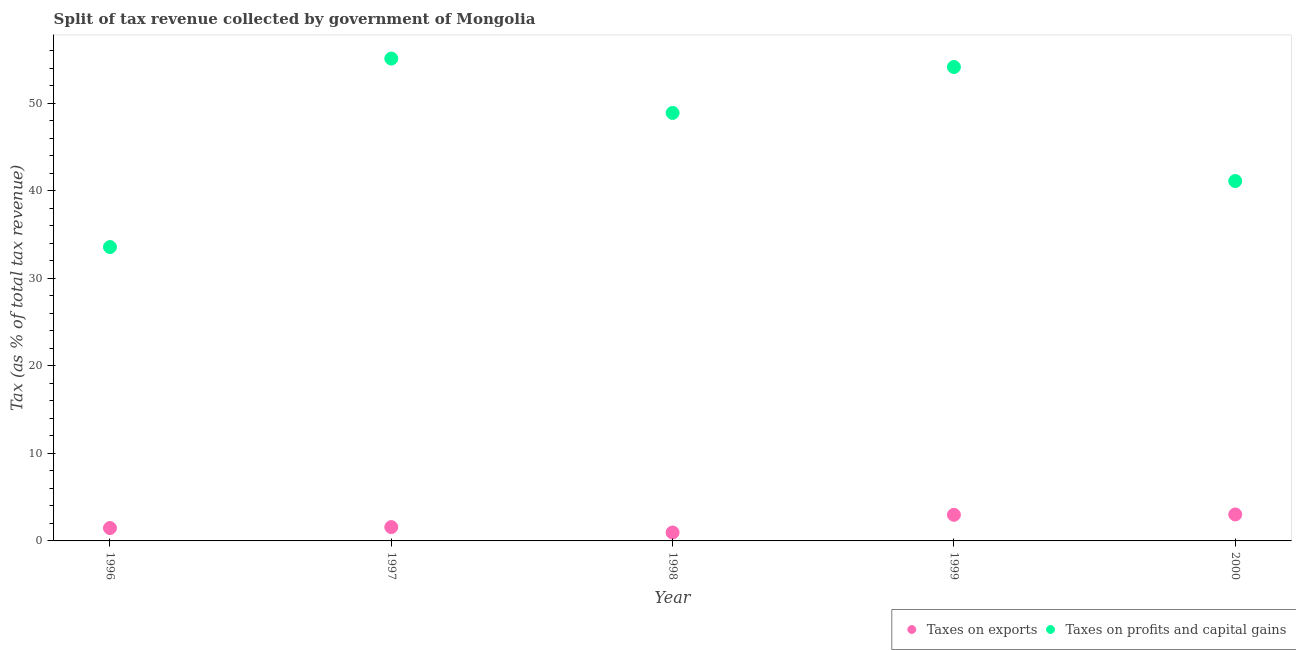How many different coloured dotlines are there?
Your answer should be very brief. 2. What is the percentage of revenue obtained from taxes on exports in 1999?
Offer a very short reply. 2.98. Across all years, what is the maximum percentage of revenue obtained from taxes on exports?
Make the answer very short. 3.03. Across all years, what is the minimum percentage of revenue obtained from taxes on profits and capital gains?
Keep it short and to the point. 33.59. In which year was the percentage of revenue obtained from taxes on profits and capital gains maximum?
Give a very brief answer. 1997. In which year was the percentage of revenue obtained from taxes on exports minimum?
Ensure brevity in your answer.  1998. What is the total percentage of revenue obtained from taxes on exports in the graph?
Provide a succinct answer. 10.02. What is the difference between the percentage of revenue obtained from taxes on profits and capital gains in 1996 and that in 1999?
Your answer should be compact. -20.57. What is the difference between the percentage of revenue obtained from taxes on profits and capital gains in 1996 and the percentage of revenue obtained from taxes on exports in 2000?
Your response must be concise. 30.56. What is the average percentage of revenue obtained from taxes on profits and capital gains per year?
Give a very brief answer. 46.58. In the year 1998, what is the difference between the percentage of revenue obtained from taxes on exports and percentage of revenue obtained from taxes on profits and capital gains?
Offer a very short reply. -47.95. What is the ratio of the percentage of revenue obtained from taxes on profits and capital gains in 1999 to that in 2000?
Keep it short and to the point. 1.32. What is the difference between the highest and the second highest percentage of revenue obtained from taxes on profits and capital gains?
Your answer should be very brief. 0.97. What is the difference between the highest and the lowest percentage of revenue obtained from taxes on exports?
Provide a succinct answer. 2.06. In how many years, is the percentage of revenue obtained from taxes on exports greater than the average percentage of revenue obtained from taxes on exports taken over all years?
Your response must be concise. 2. Is the sum of the percentage of revenue obtained from taxes on profits and capital gains in 1998 and 1999 greater than the maximum percentage of revenue obtained from taxes on exports across all years?
Give a very brief answer. Yes. Does the percentage of revenue obtained from taxes on exports monotonically increase over the years?
Your response must be concise. No. Is the percentage of revenue obtained from taxes on exports strictly less than the percentage of revenue obtained from taxes on profits and capital gains over the years?
Offer a very short reply. Yes. Does the graph contain any zero values?
Ensure brevity in your answer.  No. Does the graph contain grids?
Give a very brief answer. No. Where does the legend appear in the graph?
Offer a very short reply. Bottom right. How are the legend labels stacked?
Your response must be concise. Horizontal. What is the title of the graph?
Provide a short and direct response. Split of tax revenue collected by government of Mongolia. Does "Start a business" appear as one of the legend labels in the graph?
Offer a terse response. No. What is the label or title of the Y-axis?
Make the answer very short. Tax (as % of total tax revenue). What is the Tax (as % of total tax revenue) of Taxes on exports in 1996?
Keep it short and to the point. 1.47. What is the Tax (as % of total tax revenue) of Taxes on profits and capital gains in 1996?
Provide a short and direct response. 33.59. What is the Tax (as % of total tax revenue) in Taxes on exports in 1997?
Your answer should be very brief. 1.58. What is the Tax (as % of total tax revenue) of Taxes on profits and capital gains in 1997?
Your response must be concise. 55.12. What is the Tax (as % of total tax revenue) in Taxes on exports in 1998?
Offer a terse response. 0.96. What is the Tax (as % of total tax revenue) of Taxes on profits and capital gains in 1998?
Keep it short and to the point. 48.91. What is the Tax (as % of total tax revenue) of Taxes on exports in 1999?
Make the answer very short. 2.98. What is the Tax (as % of total tax revenue) of Taxes on profits and capital gains in 1999?
Make the answer very short. 54.16. What is the Tax (as % of total tax revenue) of Taxes on exports in 2000?
Make the answer very short. 3.03. What is the Tax (as % of total tax revenue) in Taxes on profits and capital gains in 2000?
Provide a short and direct response. 41.13. Across all years, what is the maximum Tax (as % of total tax revenue) of Taxes on exports?
Offer a terse response. 3.03. Across all years, what is the maximum Tax (as % of total tax revenue) of Taxes on profits and capital gains?
Your answer should be very brief. 55.12. Across all years, what is the minimum Tax (as % of total tax revenue) in Taxes on exports?
Your answer should be compact. 0.96. Across all years, what is the minimum Tax (as % of total tax revenue) of Taxes on profits and capital gains?
Provide a short and direct response. 33.59. What is the total Tax (as % of total tax revenue) of Taxes on exports in the graph?
Keep it short and to the point. 10.02. What is the total Tax (as % of total tax revenue) in Taxes on profits and capital gains in the graph?
Give a very brief answer. 232.91. What is the difference between the Tax (as % of total tax revenue) of Taxes on exports in 1996 and that in 1997?
Offer a very short reply. -0.11. What is the difference between the Tax (as % of total tax revenue) of Taxes on profits and capital gains in 1996 and that in 1997?
Offer a very short reply. -21.54. What is the difference between the Tax (as % of total tax revenue) of Taxes on exports in 1996 and that in 1998?
Make the answer very short. 0.51. What is the difference between the Tax (as % of total tax revenue) in Taxes on profits and capital gains in 1996 and that in 1998?
Your response must be concise. -15.33. What is the difference between the Tax (as % of total tax revenue) in Taxes on exports in 1996 and that in 1999?
Provide a short and direct response. -1.51. What is the difference between the Tax (as % of total tax revenue) in Taxes on profits and capital gains in 1996 and that in 1999?
Make the answer very short. -20.57. What is the difference between the Tax (as % of total tax revenue) in Taxes on exports in 1996 and that in 2000?
Provide a succinct answer. -1.55. What is the difference between the Tax (as % of total tax revenue) of Taxes on profits and capital gains in 1996 and that in 2000?
Offer a terse response. -7.55. What is the difference between the Tax (as % of total tax revenue) of Taxes on exports in 1997 and that in 1998?
Your answer should be very brief. 0.62. What is the difference between the Tax (as % of total tax revenue) in Taxes on profits and capital gains in 1997 and that in 1998?
Your answer should be compact. 6.21. What is the difference between the Tax (as % of total tax revenue) in Taxes on exports in 1997 and that in 1999?
Provide a succinct answer. -1.4. What is the difference between the Tax (as % of total tax revenue) of Taxes on profits and capital gains in 1997 and that in 1999?
Your answer should be compact. 0.97. What is the difference between the Tax (as % of total tax revenue) in Taxes on exports in 1997 and that in 2000?
Provide a short and direct response. -1.45. What is the difference between the Tax (as % of total tax revenue) in Taxes on profits and capital gains in 1997 and that in 2000?
Your response must be concise. 13.99. What is the difference between the Tax (as % of total tax revenue) in Taxes on exports in 1998 and that in 1999?
Make the answer very short. -2.02. What is the difference between the Tax (as % of total tax revenue) of Taxes on profits and capital gains in 1998 and that in 1999?
Your answer should be very brief. -5.25. What is the difference between the Tax (as % of total tax revenue) of Taxes on exports in 1998 and that in 2000?
Offer a very short reply. -2.06. What is the difference between the Tax (as % of total tax revenue) of Taxes on profits and capital gains in 1998 and that in 2000?
Provide a succinct answer. 7.78. What is the difference between the Tax (as % of total tax revenue) in Taxes on exports in 1999 and that in 2000?
Ensure brevity in your answer.  -0.04. What is the difference between the Tax (as % of total tax revenue) of Taxes on profits and capital gains in 1999 and that in 2000?
Offer a terse response. 13.03. What is the difference between the Tax (as % of total tax revenue) of Taxes on exports in 1996 and the Tax (as % of total tax revenue) of Taxes on profits and capital gains in 1997?
Your answer should be very brief. -53.65. What is the difference between the Tax (as % of total tax revenue) of Taxes on exports in 1996 and the Tax (as % of total tax revenue) of Taxes on profits and capital gains in 1998?
Your answer should be compact. -47.44. What is the difference between the Tax (as % of total tax revenue) in Taxes on exports in 1996 and the Tax (as % of total tax revenue) in Taxes on profits and capital gains in 1999?
Give a very brief answer. -52.69. What is the difference between the Tax (as % of total tax revenue) of Taxes on exports in 1996 and the Tax (as % of total tax revenue) of Taxes on profits and capital gains in 2000?
Your answer should be compact. -39.66. What is the difference between the Tax (as % of total tax revenue) in Taxes on exports in 1997 and the Tax (as % of total tax revenue) in Taxes on profits and capital gains in 1998?
Provide a succinct answer. -47.33. What is the difference between the Tax (as % of total tax revenue) of Taxes on exports in 1997 and the Tax (as % of total tax revenue) of Taxes on profits and capital gains in 1999?
Your answer should be very brief. -52.58. What is the difference between the Tax (as % of total tax revenue) in Taxes on exports in 1997 and the Tax (as % of total tax revenue) in Taxes on profits and capital gains in 2000?
Your answer should be very brief. -39.55. What is the difference between the Tax (as % of total tax revenue) in Taxes on exports in 1998 and the Tax (as % of total tax revenue) in Taxes on profits and capital gains in 1999?
Provide a short and direct response. -53.2. What is the difference between the Tax (as % of total tax revenue) in Taxes on exports in 1998 and the Tax (as % of total tax revenue) in Taxes on profits and capital gains in 2000?
Give a very brief answer. -40.17. What is the difference between the Tax (as % of total tax revenue) in Taxes on exports in 1999 and the Tax (as % of total tax revenue) in Taxes on profits and capital gains in 2000?
Provide a succinct answer. -38.15. What is the average Tax (as % of total tax revenue) of Taxes on exports per year?
Provide a succinct answer. 2. What is the average Tax (as % of total tax revenue) in Taxes on profits and capital gains per year?
Give a very brief answer. 46.58. In the year 1996, what is the difference between the Tax (as % of total tax revenue) of Taxes on exports and Tax (as % of total tax revenue) of Taxes on profits and capital gains?
Provide a succinct answer. -32.11. In the year 1997, what is the difference between the Tax (as % of total tax revenue) of Taxes on exports and Tax (as % of total tax revenue) of Taxes on profits and capital gains?
Offer a terse response. -53.54. In the year 1998, what is the difference between the Tax (as % of total tax revenue) in Taxes on exports and Tax (as % of total tax revenue) in Taxes on profits and capital gains?
Make the answer very short. -47.95. In the year 1999, what is the difference between the Tax (as % of total tax revenue) in Taxes on exports and Tax (as % of total tax revenue) in Taxes on profits and capital gains?
Give a very brief answer. -51.17. In the year 2000, what is the difference between the Tax (as % of total tax revenue) of Taxes on exports and Tax (as % of total tax revenue) of Taxes on profits and capital gains?
Provide a succinct answer. -38.1. What is the ratio of the Tax (as % of total tax revenue) of Taxes on exports in 1996 to that in 1997?
Offer a very short reply. 0.93. What is the ratio of the Tax (as % of total tax revenue) of Taxes on profits and capital gains in 1996 to that in 1997?
Your response must be concise. 0.61. What is the ratio of the Tax (as % of total tax revenue) of Taxes on exports in 1996 to that in 1998?
Provide a succinct answer. 1.53. What is the ratio of the Tax (as % of total tax revenue) in Taxes on profits and capital gains in 1996 to that in 1998?
Keep it short and to the point. 0.69. What is the ratio of the Tax (as % of total tax revenue) in Taxes on exports in 1996 to that in 1999?
Your answer should be compact. 0.49. What is the ratio of the Tax (as % of total tax revenue) of Taxes on profits and capital gains in 1996 to that in 1999?
Provide a succinct answer. 0.62. What is the ratio of the Tax (as % of total tax revenue) of Taxes on exports in 1996 to that in 2000?
Provide a short and direct response. 0.49. What is the ratio of the Tax (as % of total tax revenue) of Taxes on profits and capital gains in 1996 to that in 2000?
Your answer should be compact. 0.82. What is the ratio of the Tax (as % of total tax revenue) of Taxes on exports in 1997 to that in 1998?
Provide a short and direct response. 1.64. What is the ratio of the Tax (as % of total tax revenue) of Taxes on profits and capital gains in 1997 to that in 1998?
Give a very brief answer. 1.13. What is the ratio of the Tax (as % of total tax revenue) in Taxes on exports in 1997 to that in 1999?
Your answer should be very brief. 0.53. What is the ratio of the Tax (as % of total tax revenue) of Taxes on profits and capital gains in 1997 to that in 1999?
Your response must be concise. 1.02. What is the ratio of the Tax (as % of total tax revenue) in Taxes on exports in 1997 to that in 2000?
Offer a very short reply. 0.52. What is the ratio of the Tax (as % of total tax revenue) in Taxes on profits and capital gains in 1997 to that in 2000?
Ensure brevity in your answer.  1.34. What is the ratio of the Tax (as % of total tax revenue) of Taxes on exports in 1998 to that in 1999?
Give a very brief answer. 0.32. What is the ratio of the Tax (as % of total tax revenue) in Taxes on profits and capital gains in 1998 to that in 1999?
Keep it short and to the point. 0.9. What is the ratio of the Tax (as % of total tax revenue) in Taxes on exports in 1998 to that in 2000?
Your response must be concise. 0.32. What is the ratio of the Tax (as % of total tax revenue) of Taxes on profits and capital gains in 1998 to that in 2000?
Provide a short and direct response. 1.19. What is the ratio of the Tax (as % of total tax revenue) of Taxes on exports in 1999 to that in 2000?
Ensure brevity in your answer.  0.99. What is the ratio of the Tax (as % of total tax revenue) in Taxes on profits and capital gains in 1999 to that in 2000?
Offer a terse response. 1.32. What is the difference between the highest and the second highest Tax (as % of total tax revenue) in Taxes on exports?
Offer a terse response. 0.04. What is the difference between the highest and the second highest Tax (as % of total tax revenue) of Taxes on profits and capital gains?
Your answer should be compact. 0.97. What is the difference between the highest and the lowest Tax (as % of total tax revenue) in Taxes on exports?
Provide a short and direct response. 2.06. What is the difference between the highest and the lowest Tax (as % of total tax revenue) in Taxes on profits and capital gains?
Your answer should be compact. 21.54. 